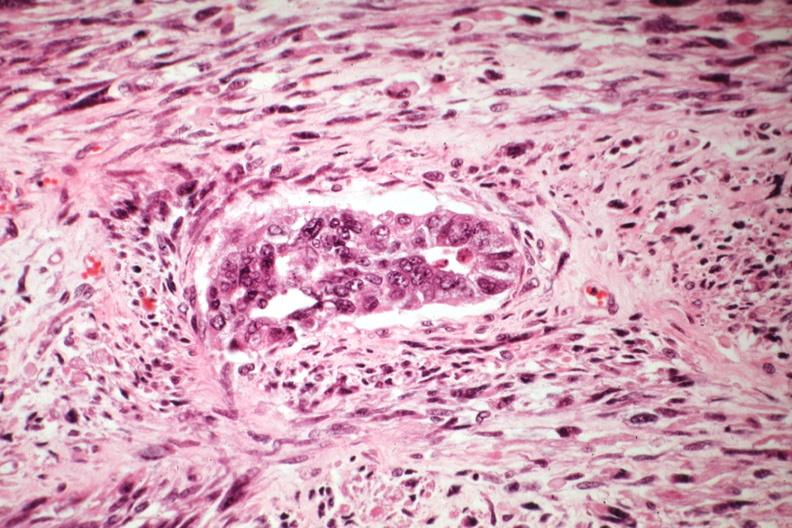what is present?
Answer the question using a single word or phrase. Mixed mesodermal tumor 